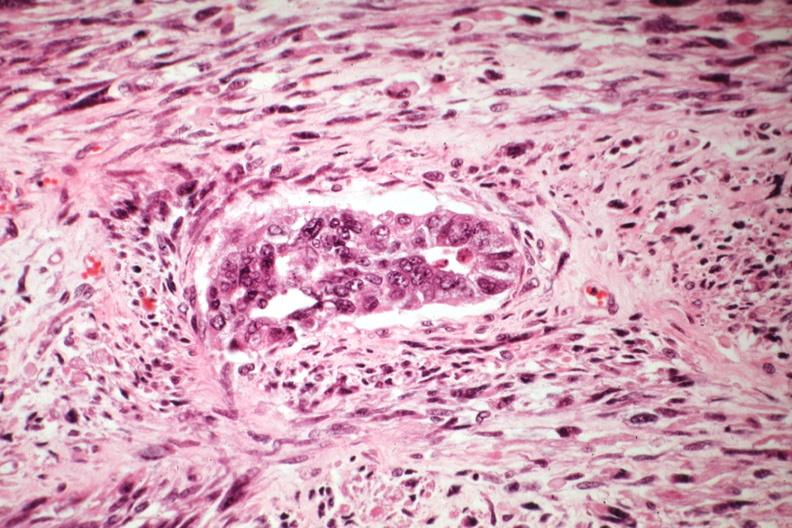what is present?
Answer the question using a single word or phrase. Mixed mesodermal tumor 